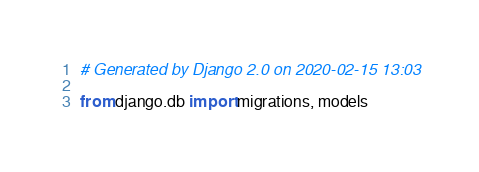Convert code to text. <code><loc_0><loc_0><loc_500><loc_500><_Python_># Generated by Django 2.0 on 2020-02-15 13:03

from django.db import migrations, models</code> 